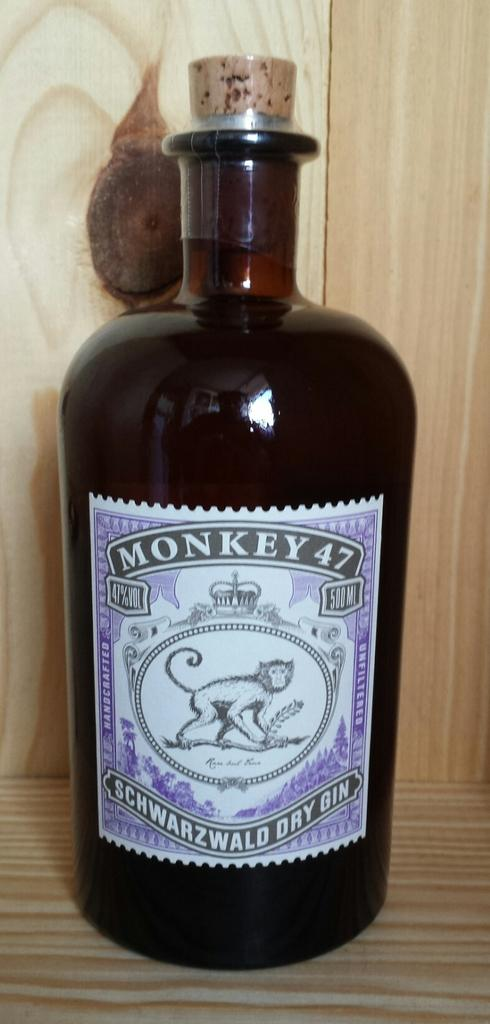<image>
Offer a succinct explanation of the picture presented. Dark bottle of Monkey 47 with a mokney on the label. 